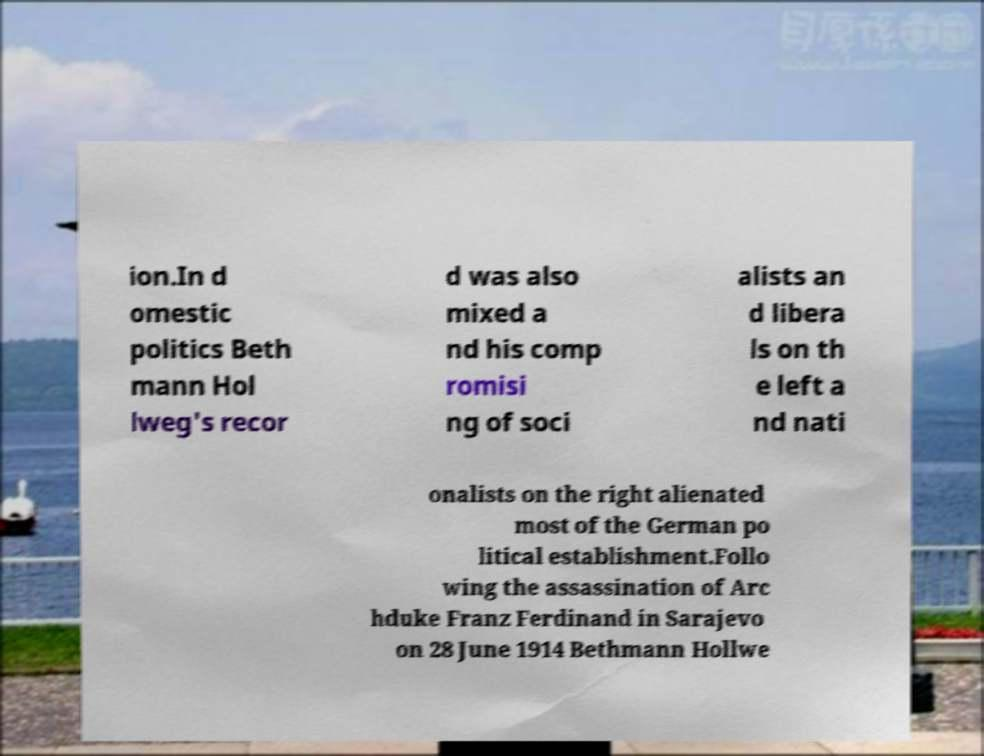Can you read and provide the text displayed in the image?This photo seems to have some interesting text. Can you extract and type it out for me? ion.In d omestic politics Beth mann Hol lweg's recor d was also mixed a nd his comp romisi ng of soci alists an d libera ls on th e left a nd nati onalists on the right alienated most of the German po litical establishment.Follo wing the assassination of Arc hduke Franz Ferdinand in Sarajevo on 28 June 1914 Bethmann Hollwe 